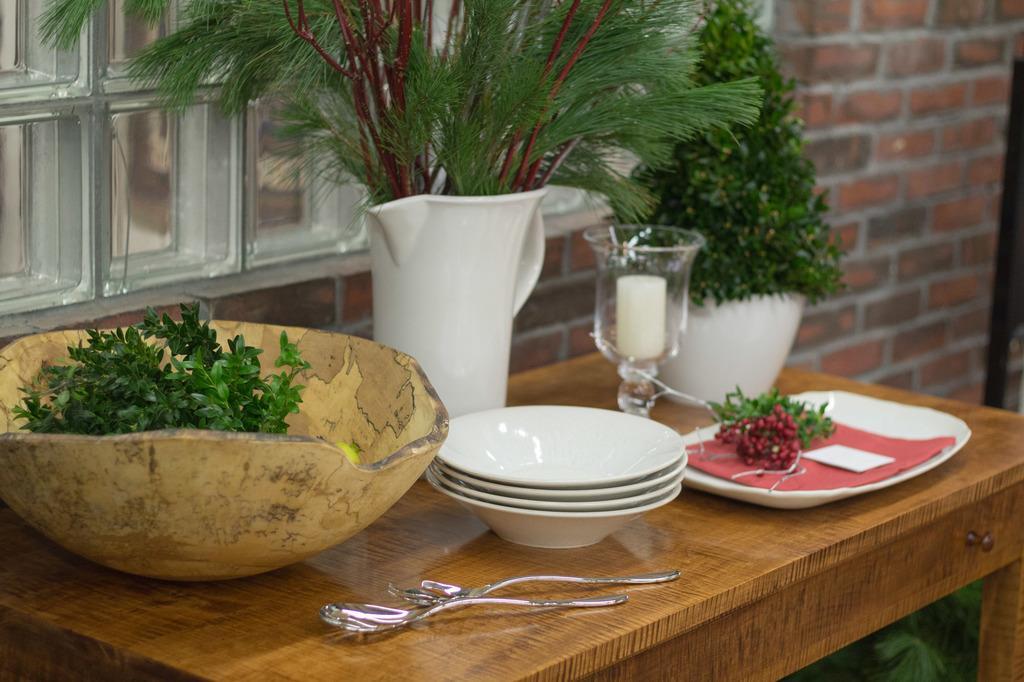How would you summarize this image in a sentence or two? In the center there is a table,on table we can see bowl,flower vase,plant,plate,paper,glass,mug,spoon and fork. In the background there is a wall and window. 